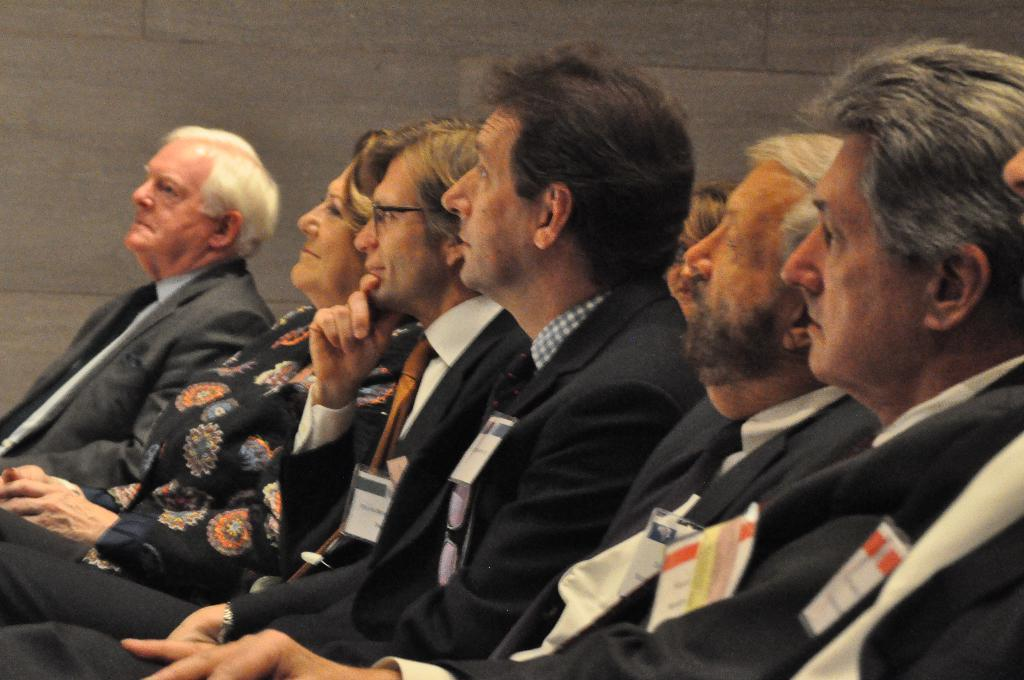What are the people in the image doing? The people in the image are sitting. Can you describe any accessories or items the people are wearing? Some of the people are wearing ID cards. What can be seen in the background of the image? There is a wall visible in the background of the image. How many snakes are slithering around the people in the image? There are no snakes present in the image. What advice does the mother give to the people in the image? There is no mention of a mother or any advice-giving in the image. 